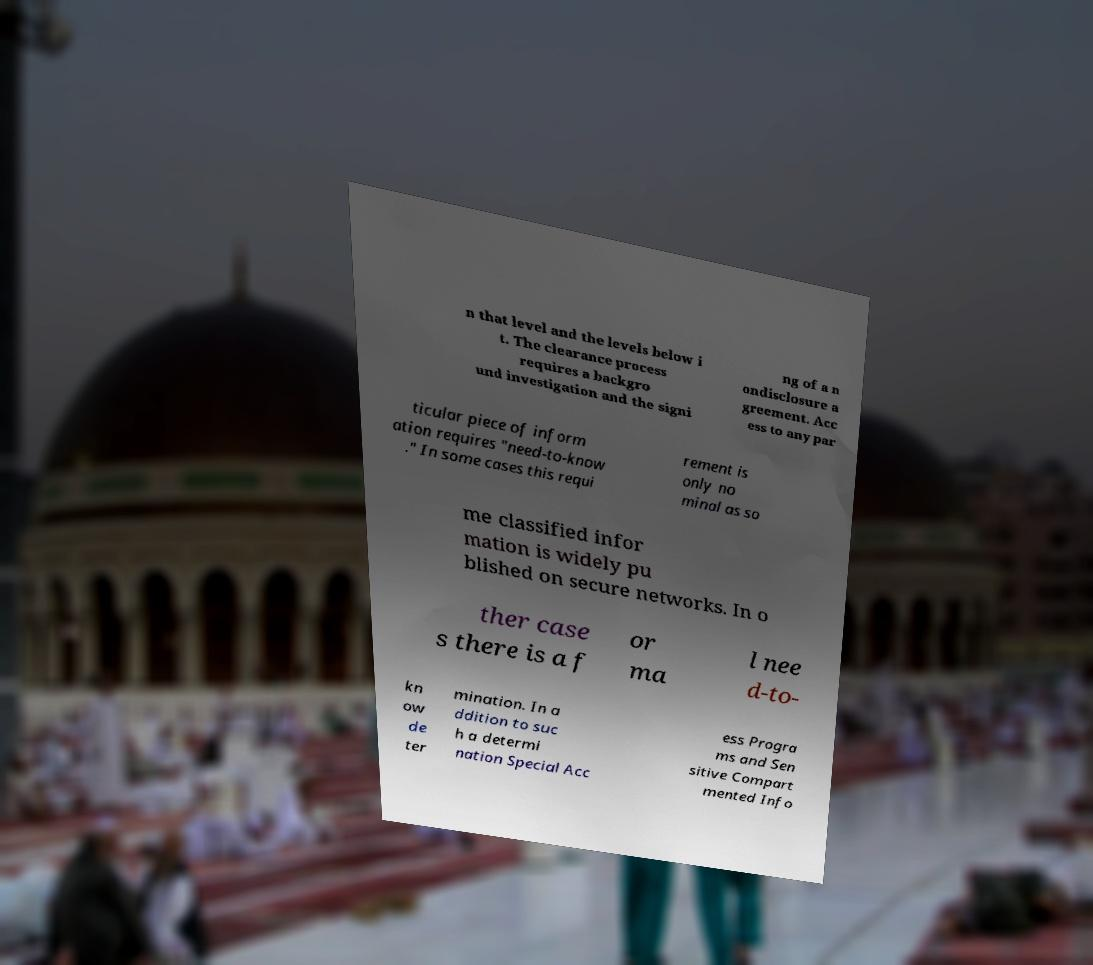For documentation purposes, I need the text within this image transcribed. Could you provide that? n that level and the levels below i t. The clearance process requires a backgro und investigation and the signi ng of a n ondisclosure a greement. Acc ess to any par ticular piece of inform ation requires "need-to-know ." In some cases this requi rement is only no minal as so me classified infor mation is widely pu blished on secure networks. In o ther case s there is a f or ma l nee d-to- kn ow de ter mination. In a ddition to suc h a determi nation Special Acc ess Progra ms and Sen sitive Compart mented Info 